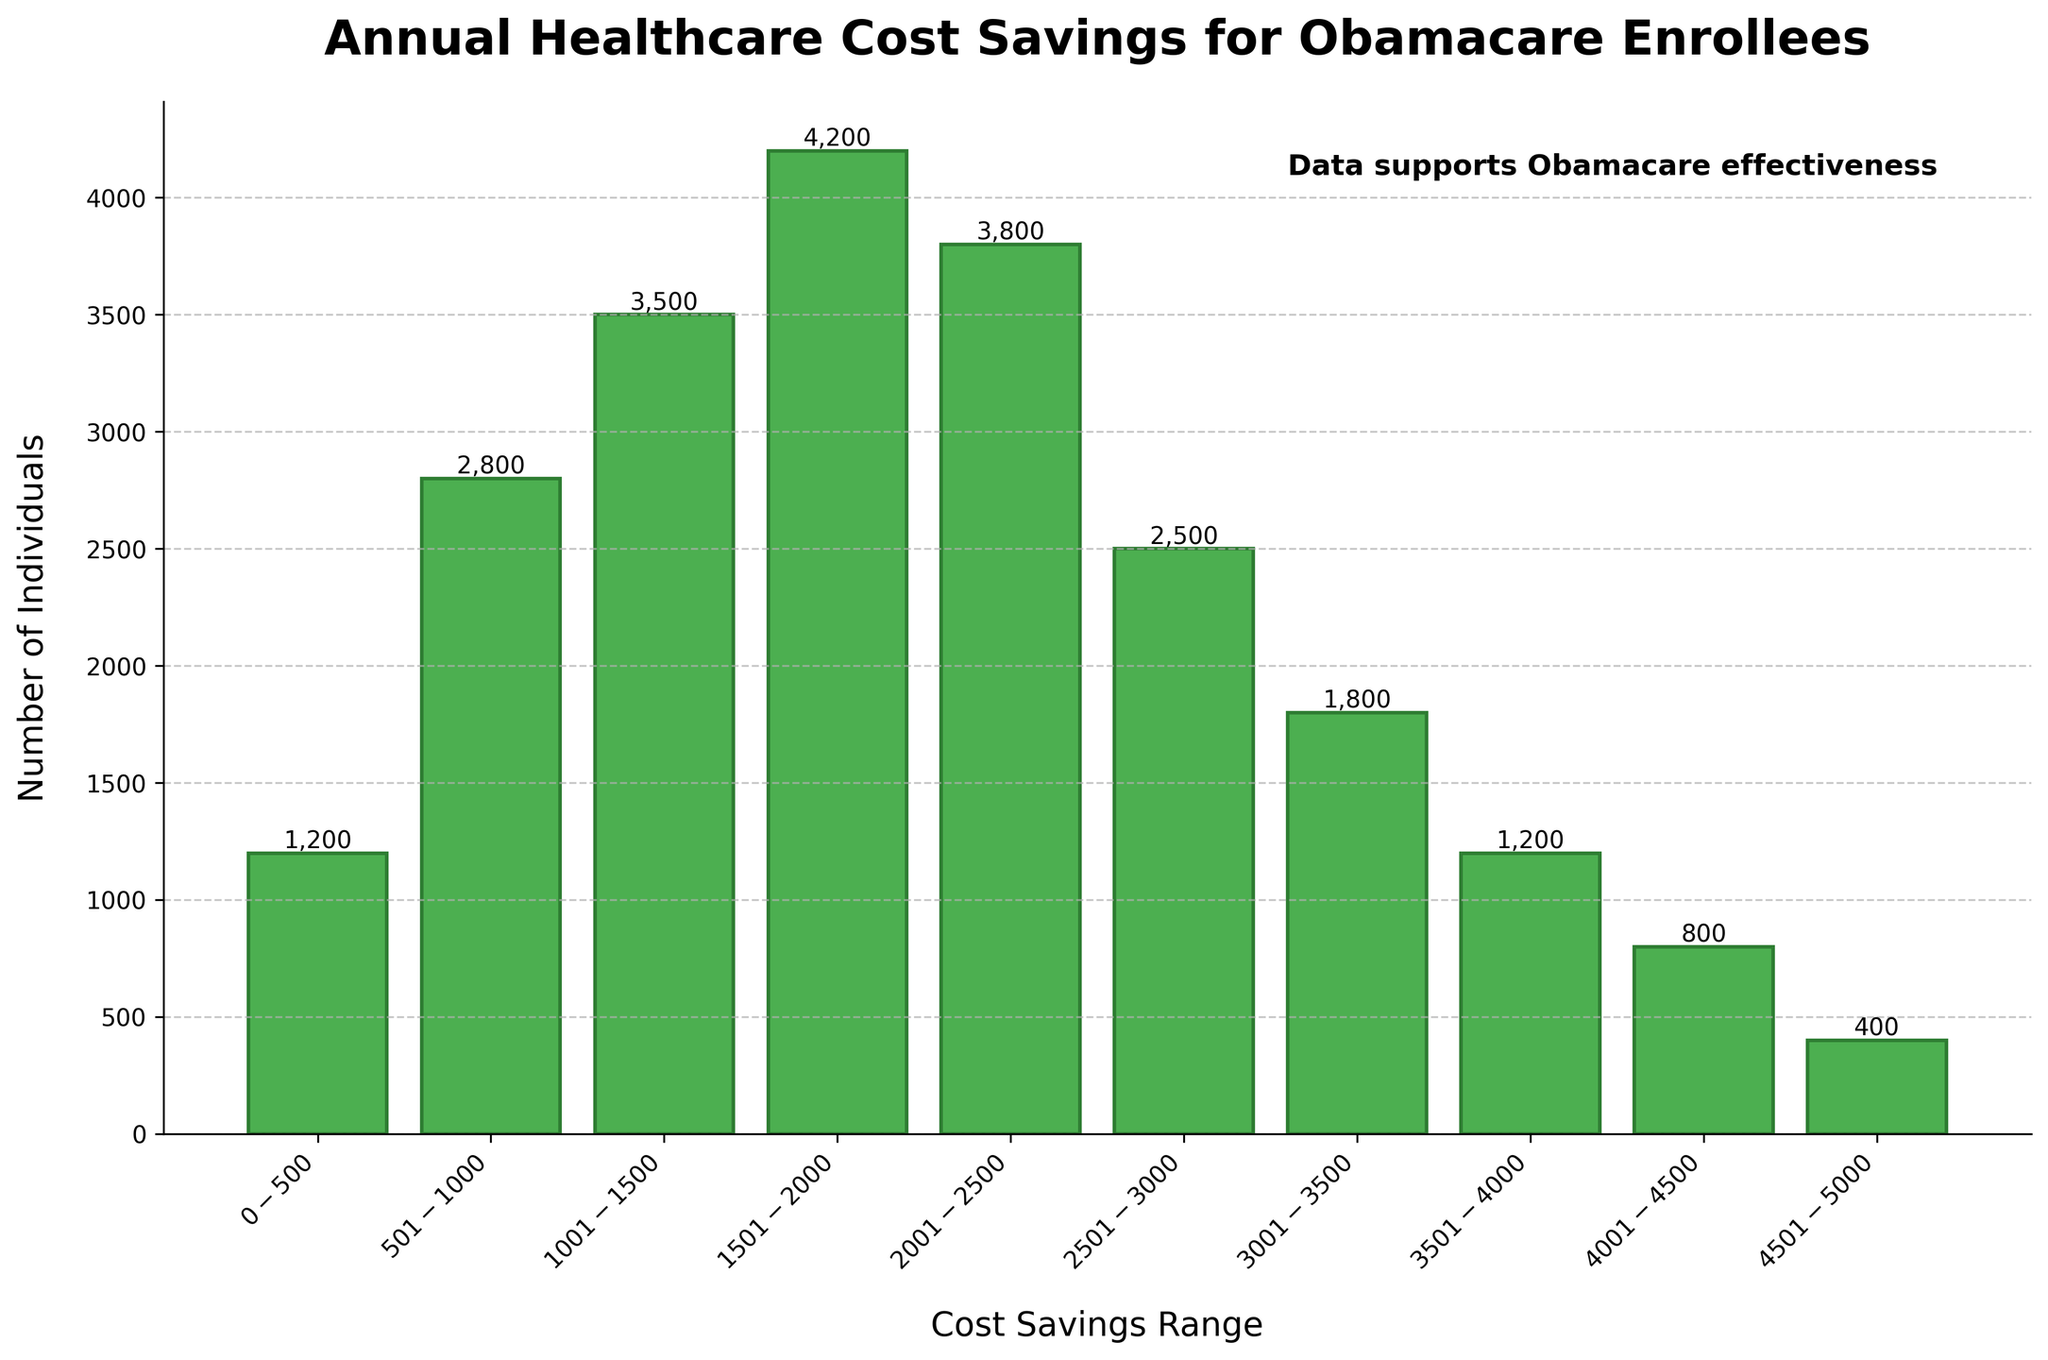What's the title of the figure? The title of the figure is located at the top center of the plot and describes the main focus or information the figure is presenting.
Answer: Annual Healthcare Cost Savings for Obamacare Enrollees How many individuals save between $1001 and $1500 annually? To find this information, locate the bar corresponding to the $1001 - $1500 range on the x-axis and read the height or value label at the top of this bar.
Answer: 3500 Which cost savings range has the highest number of individuals? Identify the tallest bar in the histogram as it represents the highest number of individuals. Look at the x-axis label below this bar to determine the corresponding cost savings range.
Answer: $1501 - $2000 How many more individuals save between $501 and $1000 than between $3001 and $3500? First, identify the number of individuals for the $501 - $1000 range (2800) and the $3001 - $3500 range (1800). Then, subtract the latter from the former to calculate the difference. 2800 - 1800 = 1000.
Answer: 1000 What is the range of healthcare cost savings where the least number of individuals are enrolled? Locate the shortest bar in the histogram, then check the x-axis label below this bar to find the corresponding cost savings range.
Answer: $4501 - $5000 What are the two ranges with the closest number of individuals? Identify bars with similar heights and look at their respective labels on the x-axis. Compare the actual values to find the two ranges with the closest numbers. Here, $0 - $500 (1200) and $3501 - $4000 (1200) have the exact same number of individuals.
Answer: $0 - $500 and $3501 - $4000 How many total individuals save over $3000 annually? Add the number of individuals in the ranges $3001 - $3500 (1800), $3501 - $4000 (1200), $4001 - $4500 (800), and $4501 - $5000 (400). 1800 + 1200 + 800 + 400 = 4200.
Answer: 4200 What is the average number of individuals in each cost savings range? Sum the number of individuals across all ranges (1200 + 2800 + 3500 + 4200 + 3800 + 2500 + 1800 + 1200 + 800 + 400 = 24200) and divide by the number of ranges (10). 24200 / 10 = 2420.
Answer: 2420 Which cost savings range is closest to the average number of individuals? Compute the average number of individuals (2420). Identify the range whose number of individuals is closest to this average. Compare each range's value to the average and find the closest one, which is $2001 - $2500 with 3800.
Answer: $2001 - $2500 